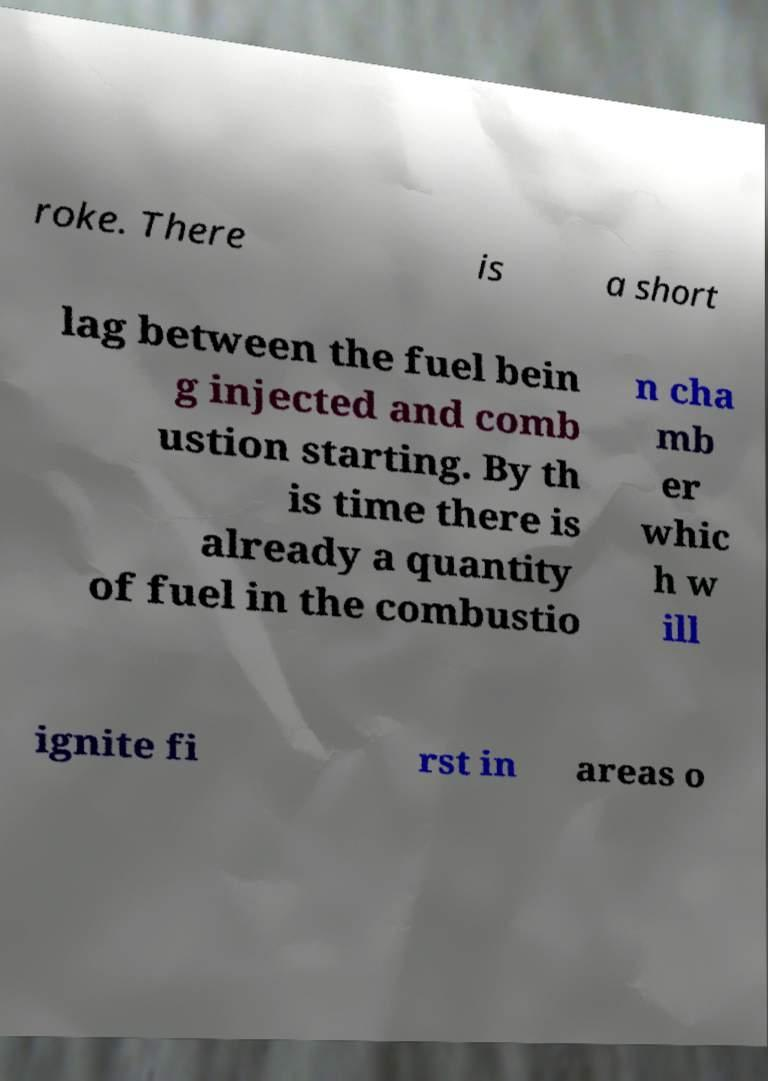Could you assist in decoding the text presented in this image and type it out clearly? roke. There is a short lag between the fuel bein g injected and comb ustion starting. By th is time there is already a quantity of fuel in the combustio n cha mb er whic h w ill ignite fi rst in areas o 